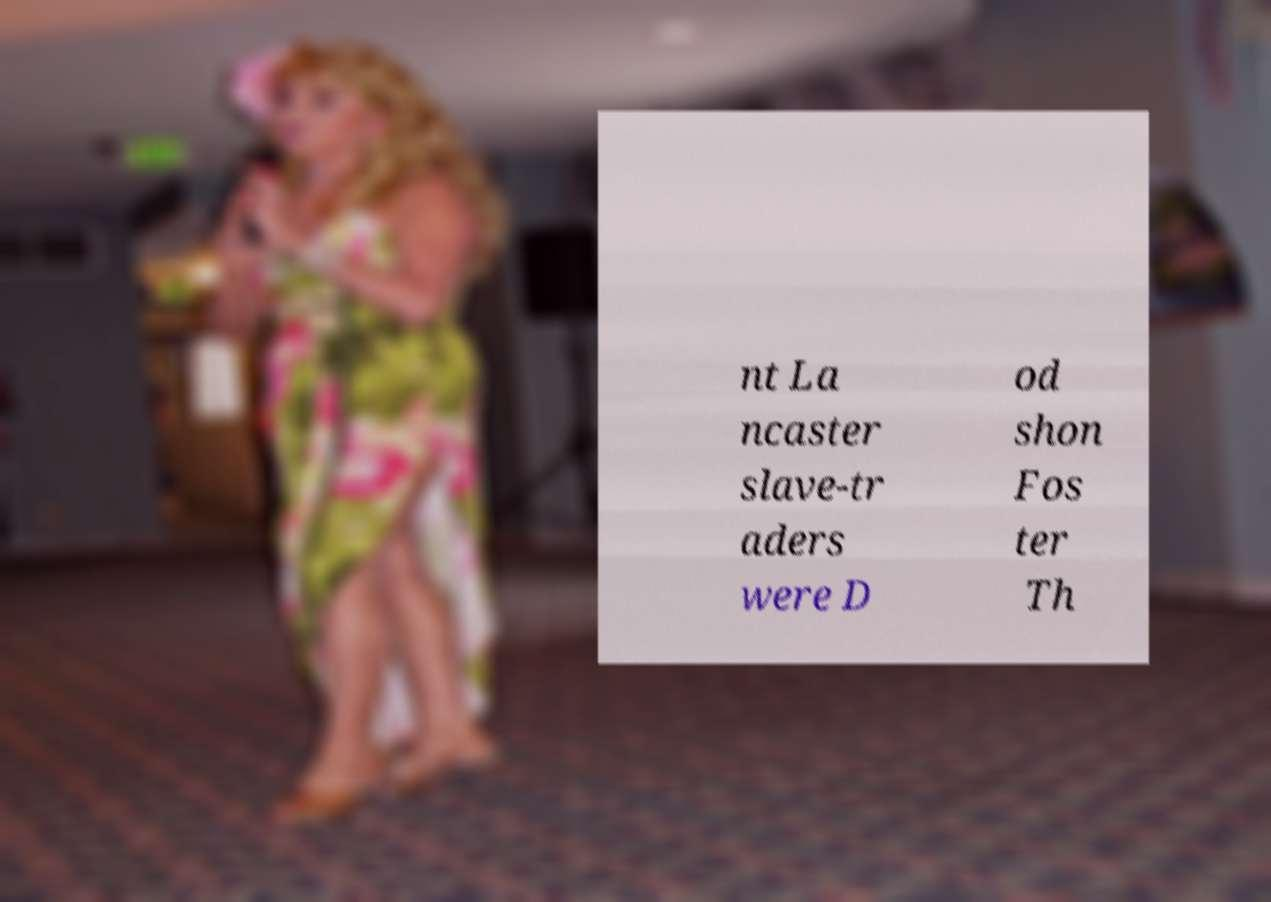There's text embedded in this image that I need extracted. Can you transcribe it verbatim? nt La ncaster slave-tr aders were D od shon Fos ter Th 